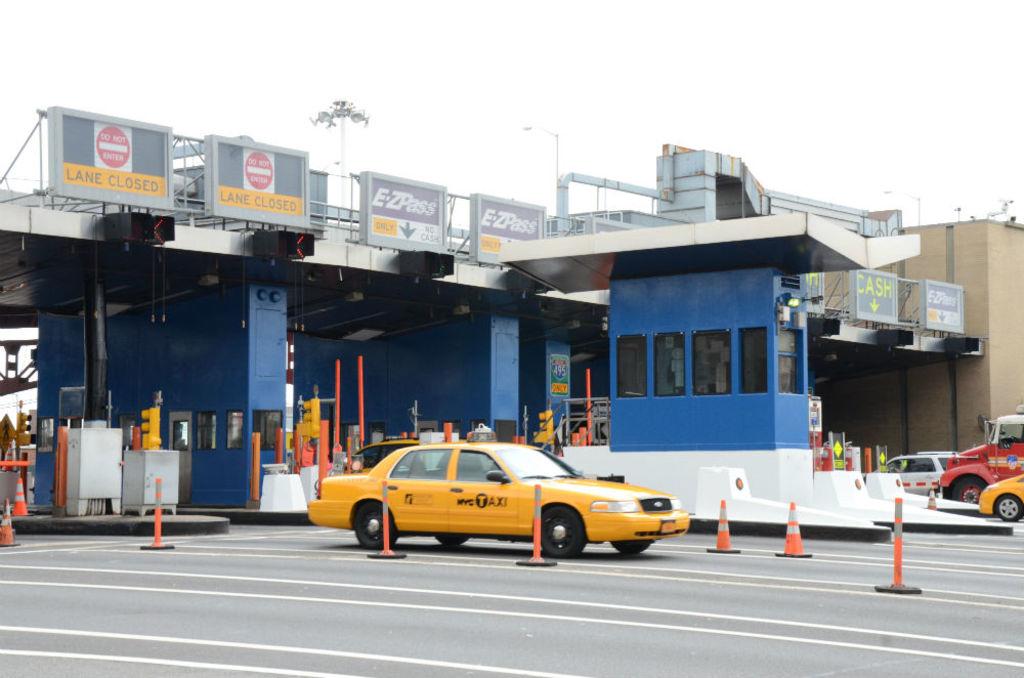Is the lane on the far left closed?
Make the answer very short. Yes. What is written on the yellow vehicle?
Make the answer very short. Nyc taxi. 